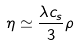<formula> <loc_0><loc_0><loc_500><loc_500>\eta \simeq \frac { \lambda c _ { s } } { 3 } \rho</formula> 